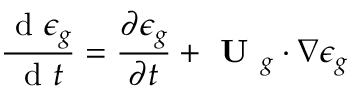Convert formula to latex. <formula><loc_0><loc_0><loc_500><loc_500>\frac { d \epsilon _ { g } } { d t } = \frac { \partial \epsilon _ { g } } { \partial t } + U _ { g } \cdot \nabla \epsilon _ { g }</formula> 